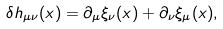Convert formula to latex. <formula><loc_0><loc_0><loc_500><loc_500>\delta h _ { \mu \nu } ( x ) = \partial _ { \mu } \xi _ { \nu } ( x ) + \partial _ { \nu } \xi _ { \mu } ( x ) ,</formula> 